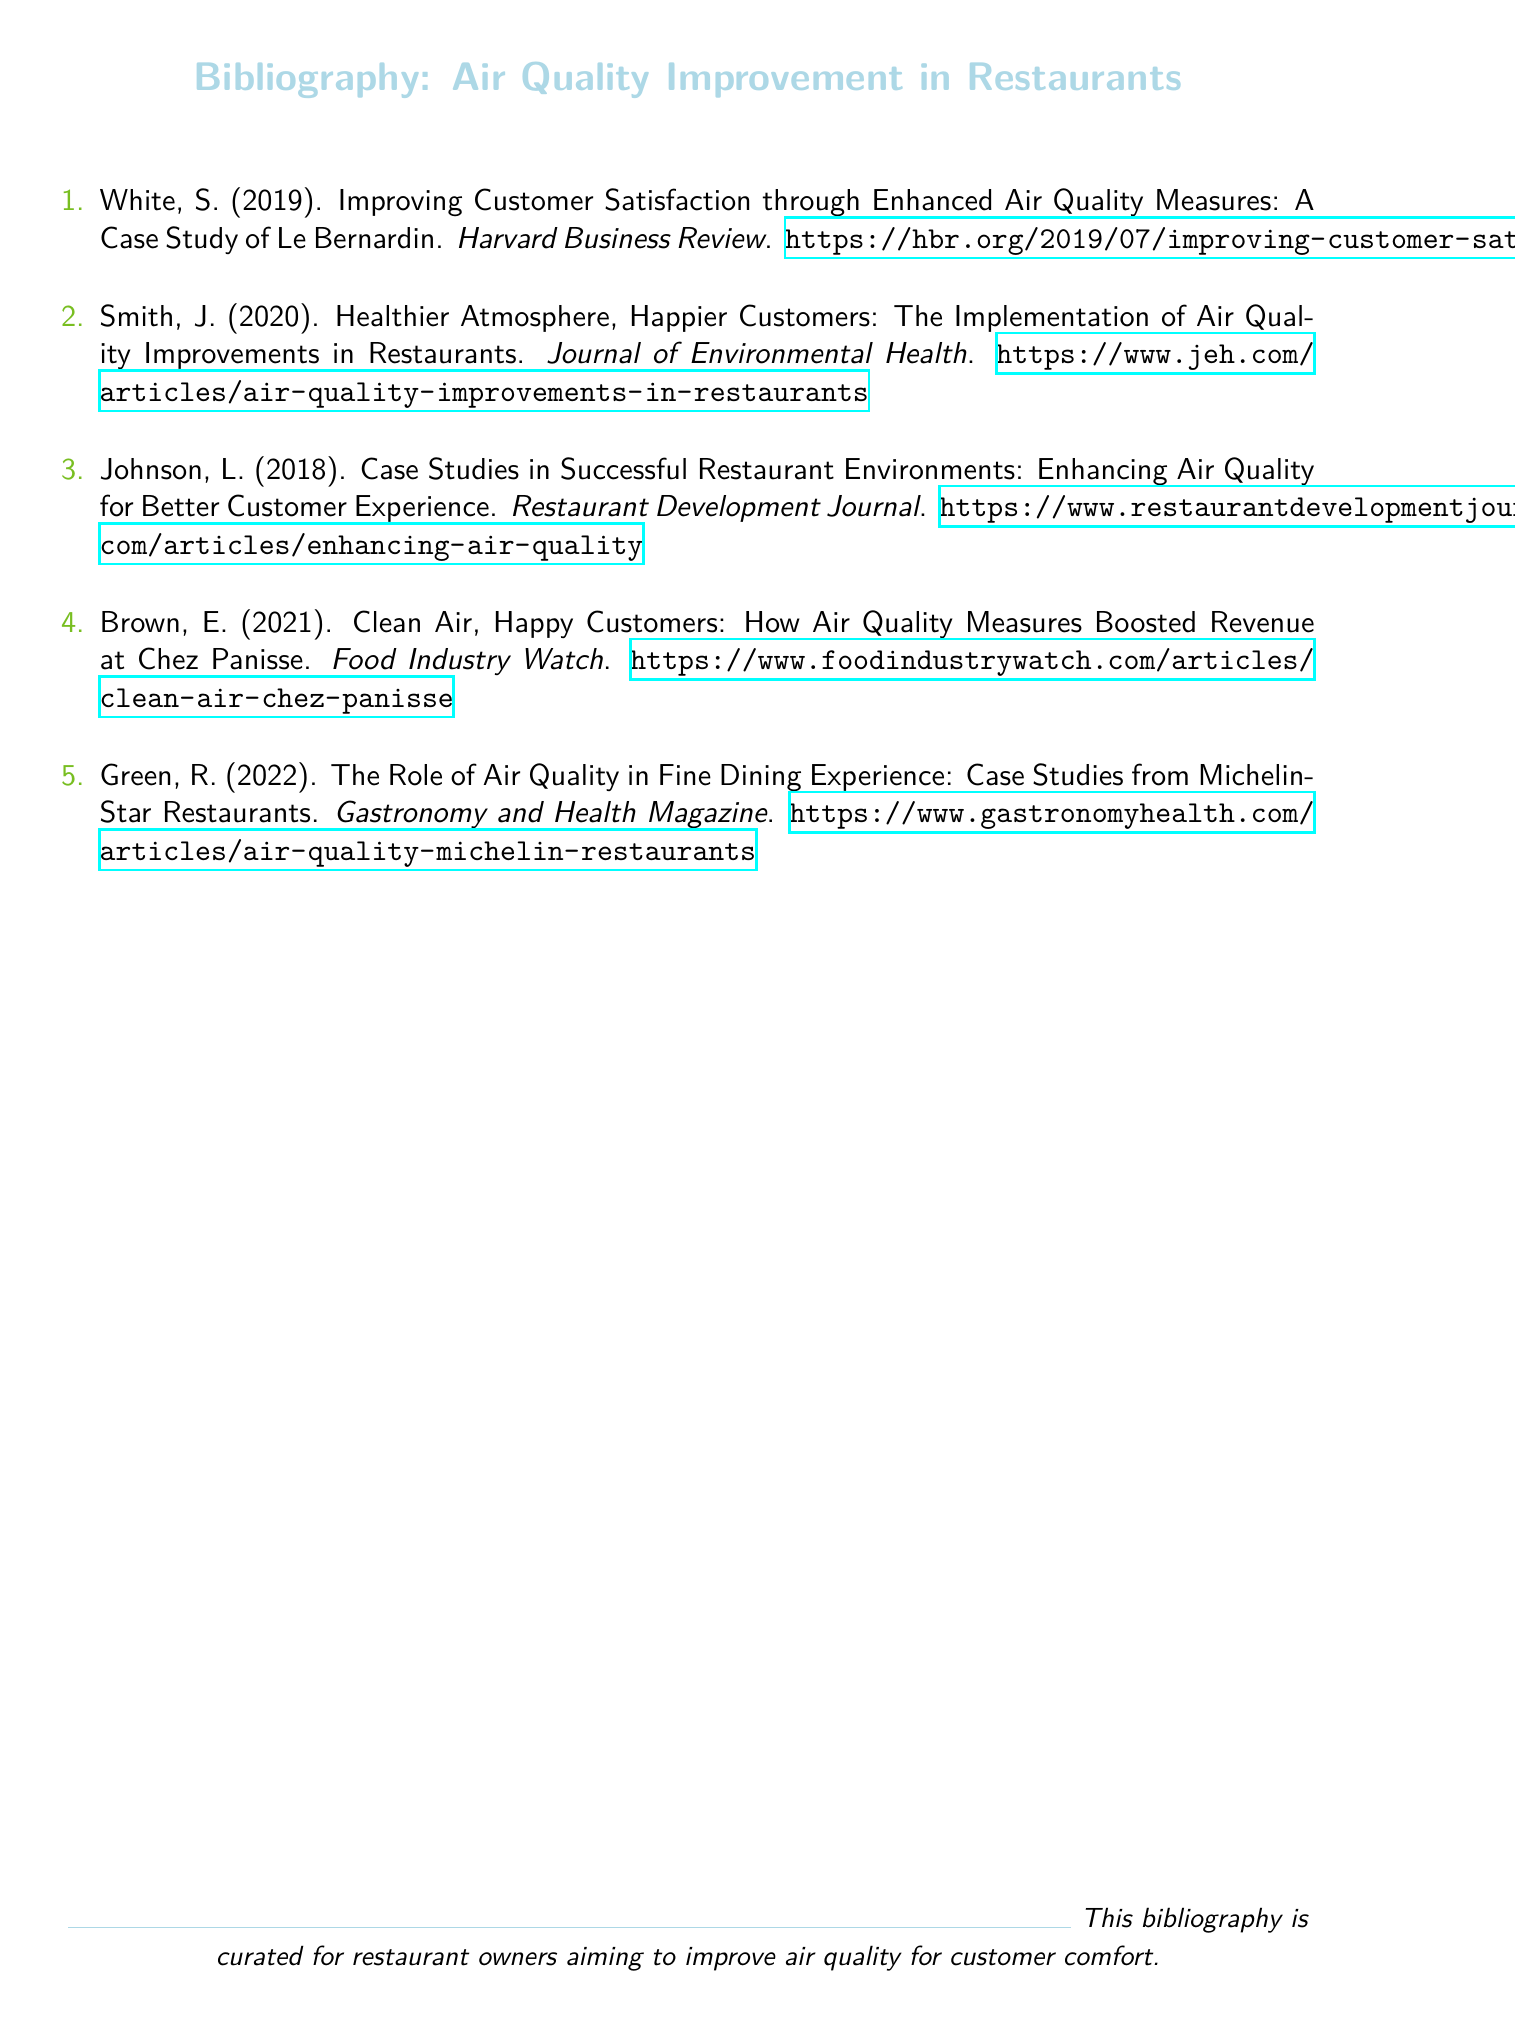What is the title of the first case study? The title of the first case study is "Improving Customer Satisfaction through Enhanced Air Quality Measures: A Case Study of Le Bernardin."
Answer: Improving Customer Satisfaction through Enhanced Air Quality Measures: A Case Study of Le Bernardin Who is the author of the case study about Chez Panisse? The author of the case study about Chez Panisse is E. Brown.
Answer: E. Brown In which year was the case study by J. Smith published? The case study by J. Smith was published in 2020.
Answer: 2020 What is the main topic covered in the bibliography? The main topic covered in the bibliography is air quality improvement in restaurants for customer comfort.
Answer: Air quality improvement in restaurants for customer comfort How many case studies are mentioned in the bibliography? There are five case studies mentioned in the bibliography.
Answer: Five What magazine published the article related to Michelin-Star Restaurants? The article related to Michelin-Star Restaurants was published in "Gastronomy and Health Magazine."
Answer: Gastronomy and Health Magazine Which case study focuses on revenue impact due to air quality measures? The case study that focuses on revenue impact due to air quality measures is "Clean Air, Happy Customers: How Air Quality Measures Boosted Revenue at Chez Panisse."
Answer: Clean Air, Happy Customers: How Air Quality Measures Boosted Revenue at Chez Panisse What color is used for the section titles? The color used for the section titles is airblue.
Answer: airblue 